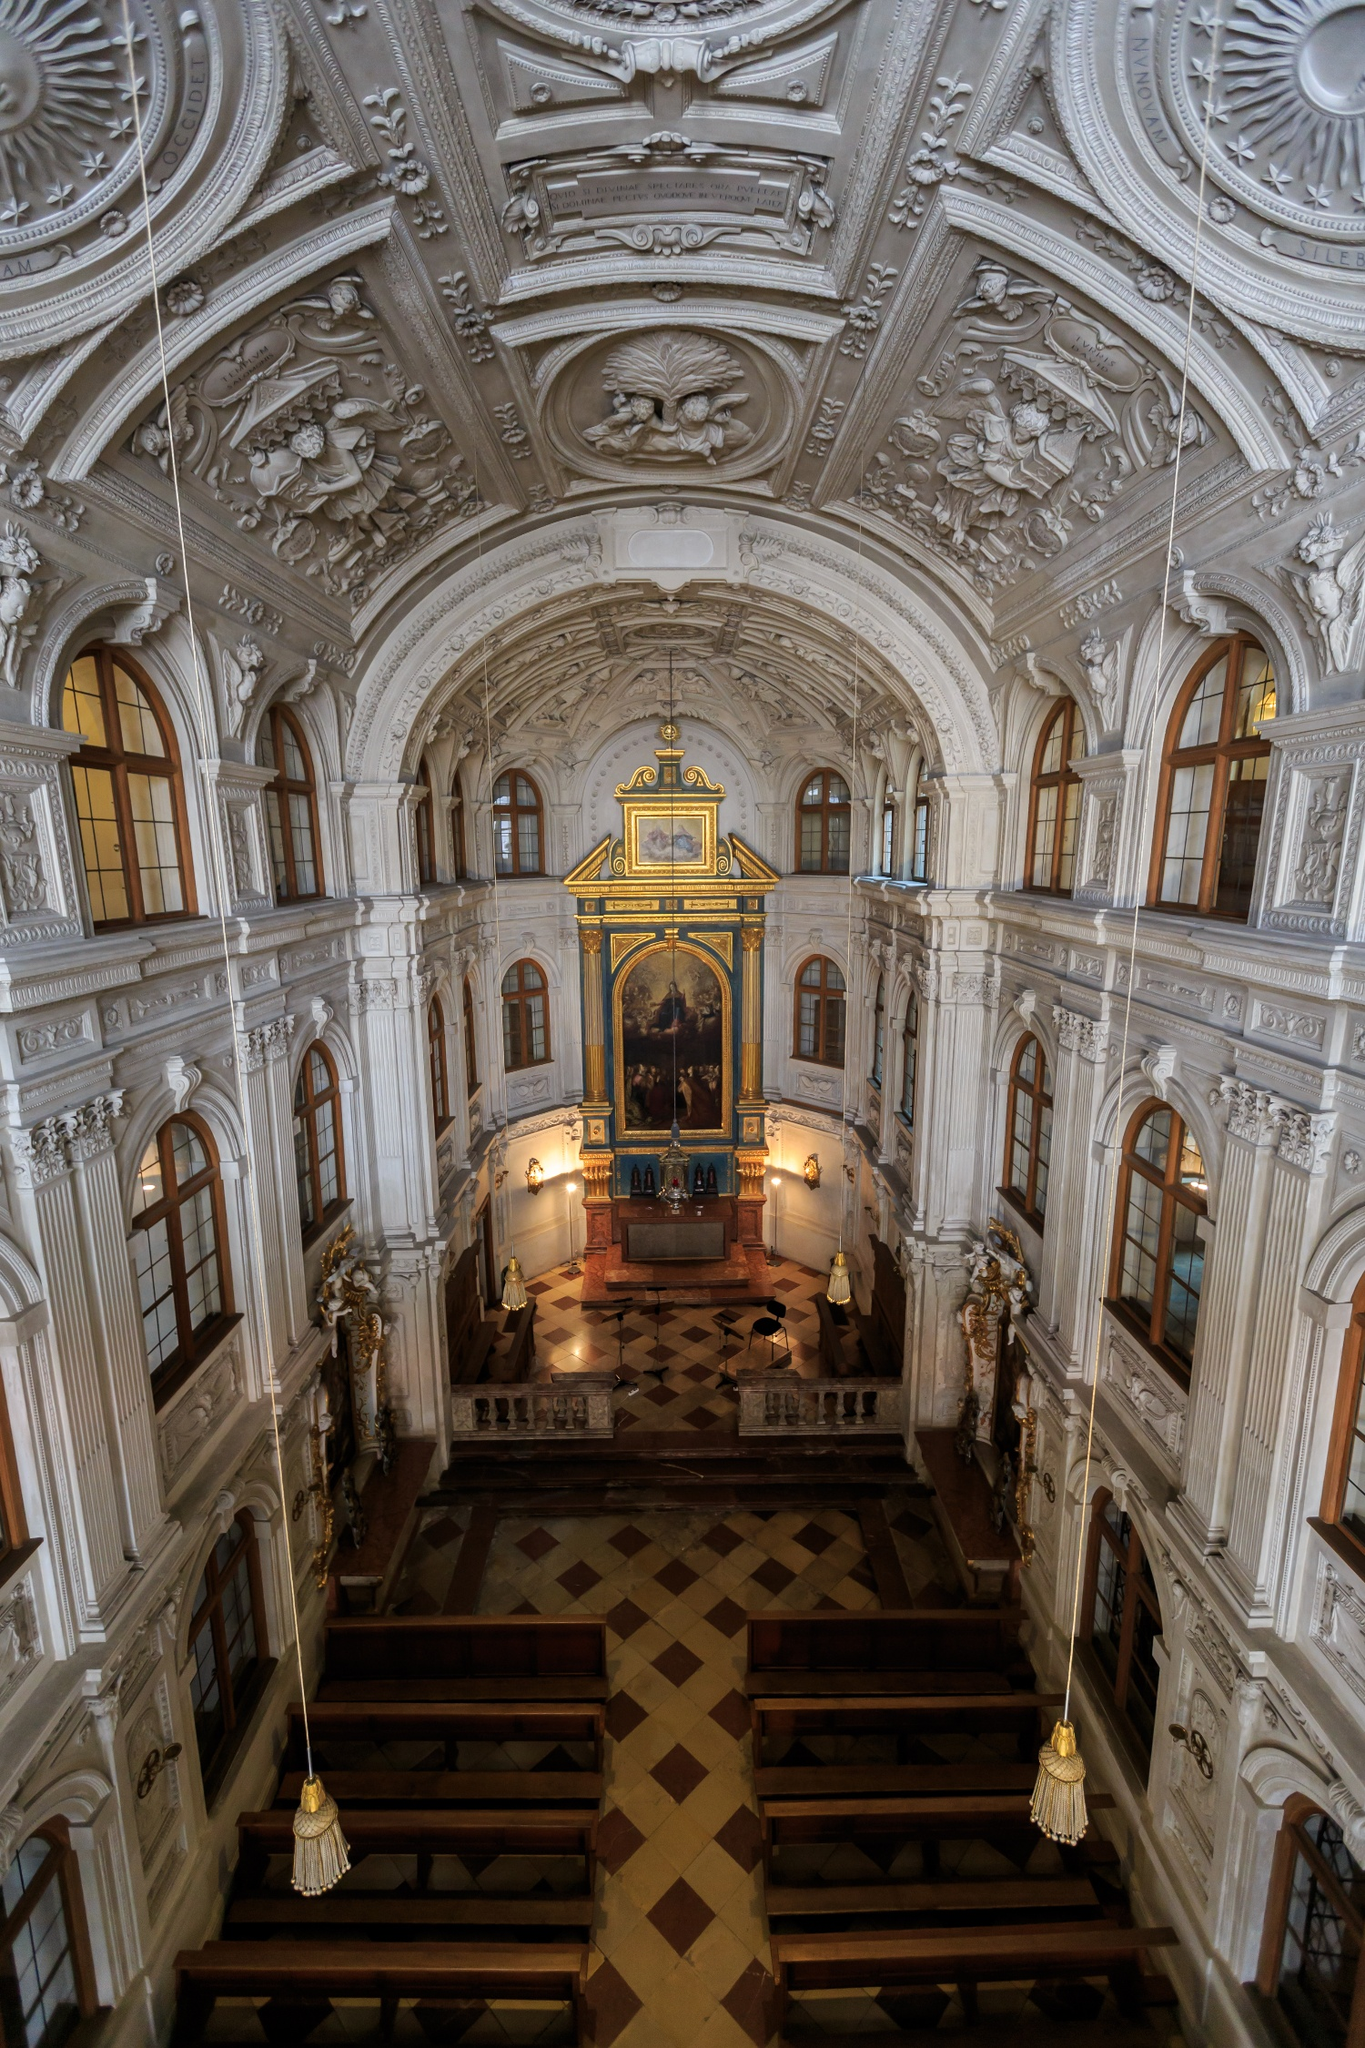Imagine this space being used as a setting for a fantasy novel. What role would it play, and what kind of adventures might unfold here? In a fantasy novel, the Hofkirche could serve as an ancient stronghold of mystical knowledge and power. Hidden within its baroque splendor are secret tomes and relics waiting to be discovered by a group of young adventurers. The church might be guarded by ethereal spirits and enchanted creatures that protect the secrets from falling into the wrong hands. The protagonists could uncover a prophecy carved into the stucco work, leading them on a quest to prevent an impending catastrophe. Rituals conducted at the altar might unlock portals to other realms, setting the stage for thrilling escapades across magical landscapes. This sacred site becomes the nexus where the fate of kingdoms is decided, transforming the church into an enduring symbol of hope and resilience in the face of darkness. 